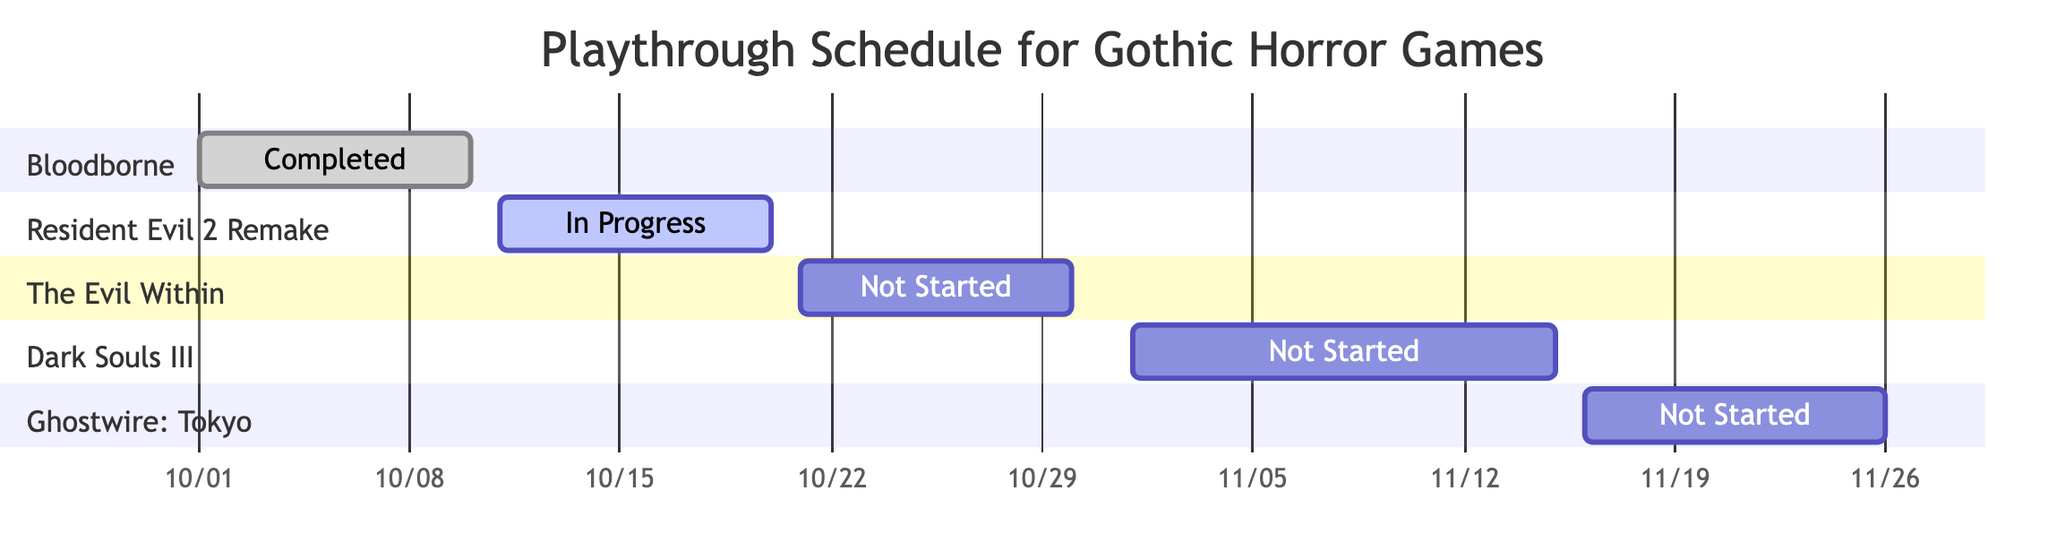What is the total number of games listed in the schedule? The diagram contains five sections representing different games: Bloodborne, Resident Evil 2 Remake, The Evil Within, Dark Souls III, and Ghostwire: Tokyo. Therefore, the total count of games is five.
Answer: 5 Which game has the longest allocated time? By checking the allocated time for each game: Bloodborne has 40 hours, Resident Evil 2 Remake has 20 hours, The Evil Within has 30 hours, Dark Souls III has 50 hours, and Ghostwire: Tokyo has 25 hours. Dark Souls III has the longest allocation with 50 hours.
Answer: Dark Souls III What is the completion status of Resident Evil 2 Remake? The diagram shows the section for Resident Evil 2 Remake is labeled "In Progress," which indicates its current completion status.
Answer: In Progress How many games are not started yet? The diagram lists three games that are marked "Not Started": The Evil Within, Dark Souls III, and Ghostwire: Tokyo. Therefore, the count of games not started is three.
Answer: 3 When does the playthrough of Ghostwire: Tokyo start? The section for Ghostwire: Tokyo indicates that the playthrough starts on November 16, 2023, which is noted in the start date of its section.
Answer: November 16, 2023 What is the allocated time for The Evil Within? Looking at the diagram, The Evil Within shows an allocated time of 30 hours specified in its section.
Answer: 30 hours Which game is currently being played? According to the diagram, the game that shows as "active" is Resident Evil 2 Remake, indicating it is currently in play.
Answer: Resident Evil 2 Remake What is the ending date for Dark Souls III? The section for Dark Souls III specifies an end date of November 15, 2023, which is indicated in its timeline in the diagram.
Answer: November 15, 2023 